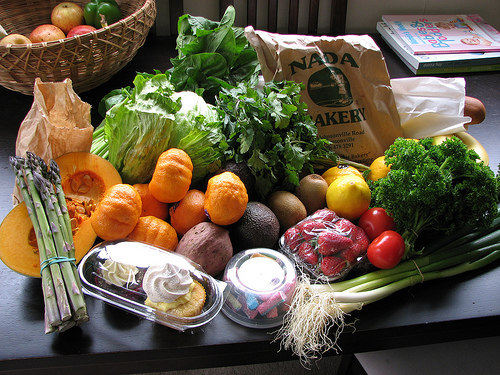<image>
Is there a asparagus on the squash? Yes. Looking at the image, I can see the asparagus is positioned on top of the squash, with the squash providing support. 